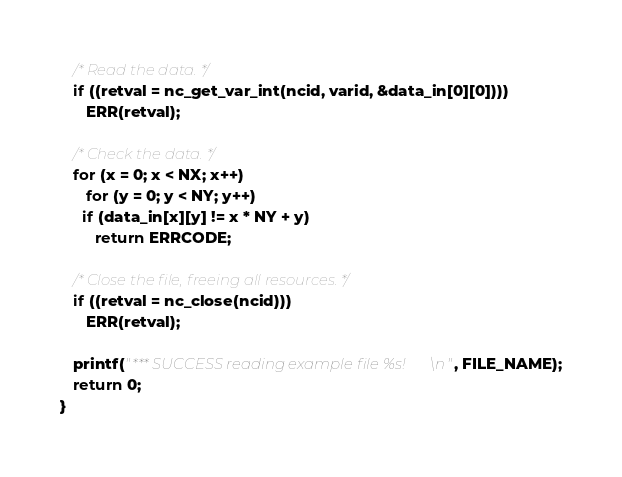<code> <loc_0><loc_0><loc_500><loc_500><_C_>
   /* Read the data. */
   if ((retval = nc_get_var_int(ncid, varid, &data_in[0][0])))
      ERR(retval);

   /* Check the data. */
   for (x = 0; x < NX; x++)
      for (y = 0; y < NY; y++)
	 if (data_in[x][y] != x * NY + y)
	    return ERRCODE;

   /* Close the file, freeing all resources. */
   if ((retval = nc_close(ncid)))
      ERR(retval);

   printf("*** SUCCESS reading example file %s!\n", FILE_NAME);
   return 0;
}
</code> 